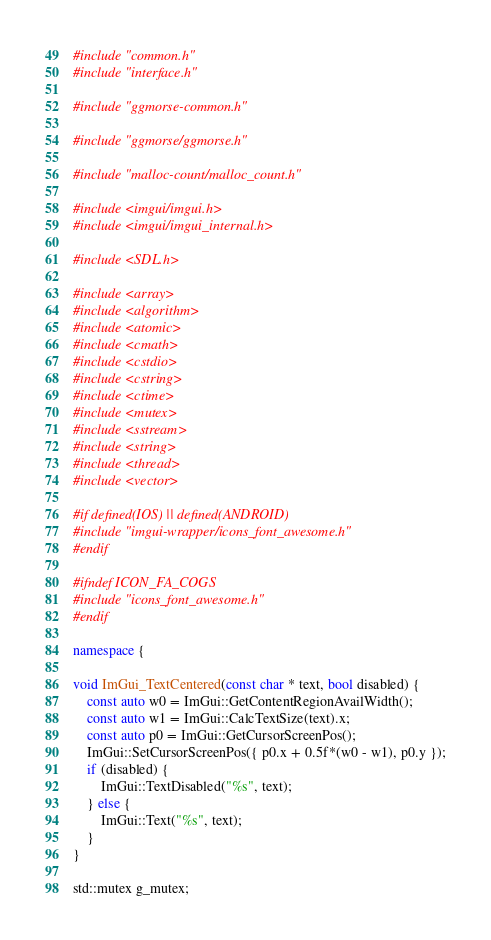<code> <loc_0><loc_0><loc_500><loc_500><_C++_>#include "common.h"
#include "interface.h"

#include "ggmorse-common.h"

#include "ggmorse/ggmorse.h"

#include "malloc-count/malloc_count.h"

#include <imgui/imgui.h>
#include <imgui/imgui_internal.h>

#include <SDL.h>

#include <array>
#include <algorithm>
#include <atomic>
#include <cmath>
#include <cstdio>
#include <cstring>
#include <ctime>
#include <mutex>
#include <sstream>
#include <string>
#include <thread>
#include <vector>

#if defined(IOS) || defined(ANDROID)
#include "imgui-wrapper/icons_font_awesome.h"
#endif

#ifndef ICON_FA_COGS
#include "icons_font_awesome.h"
#endif

namespace {

void ImGui_TextCentered(const char * text, bool disabled) {
    const auto w0 = ImGui::GetContentRegionAvailWidth();
    const auto w1 = ImGui::CalcTextSize(text).x;
    const auto p0 = ImGui::GetCursorScreenPos();
    ImGui::SetCursorScreenPos({ p0.x + 0.5f*(w0 - w1), p0.y });
    if (disabled) {
        ImGui::TextDisabled("%s", text);
    } else {
        ImGui::Text("%s", text);
    }
}

std::mutex g_mutex;</code> 